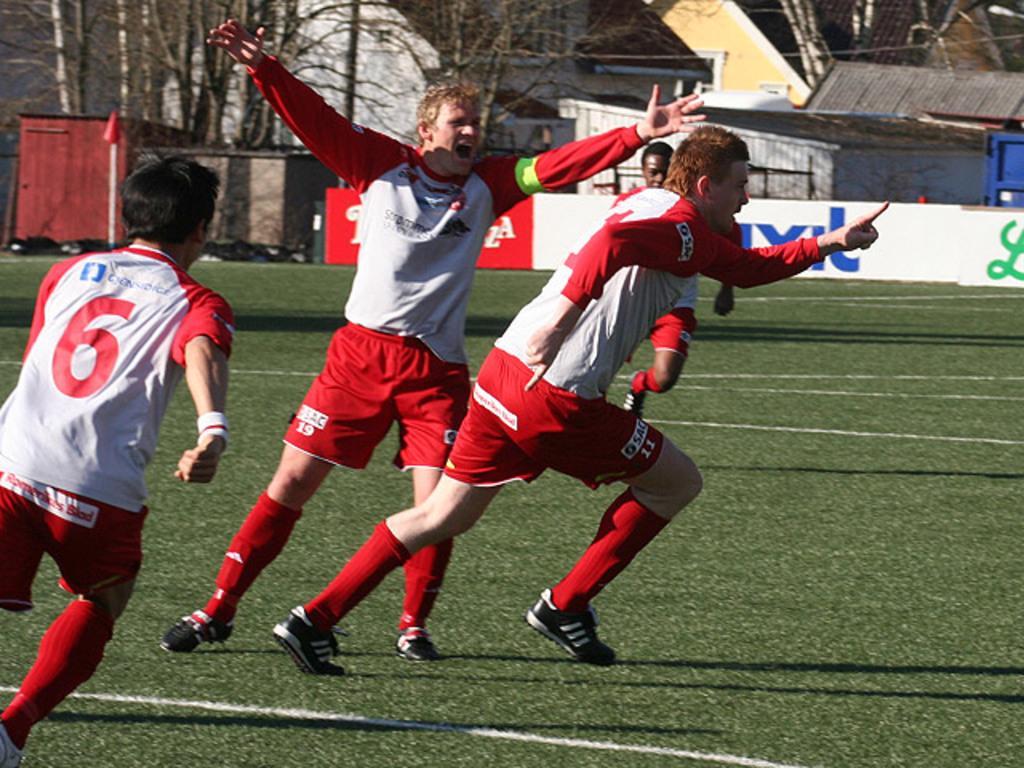In one or two sentences, can you explain what this image depicts? In the foreground of this image, there are four men running on the grass. In the background, there is a banner, few buildings and trees. 